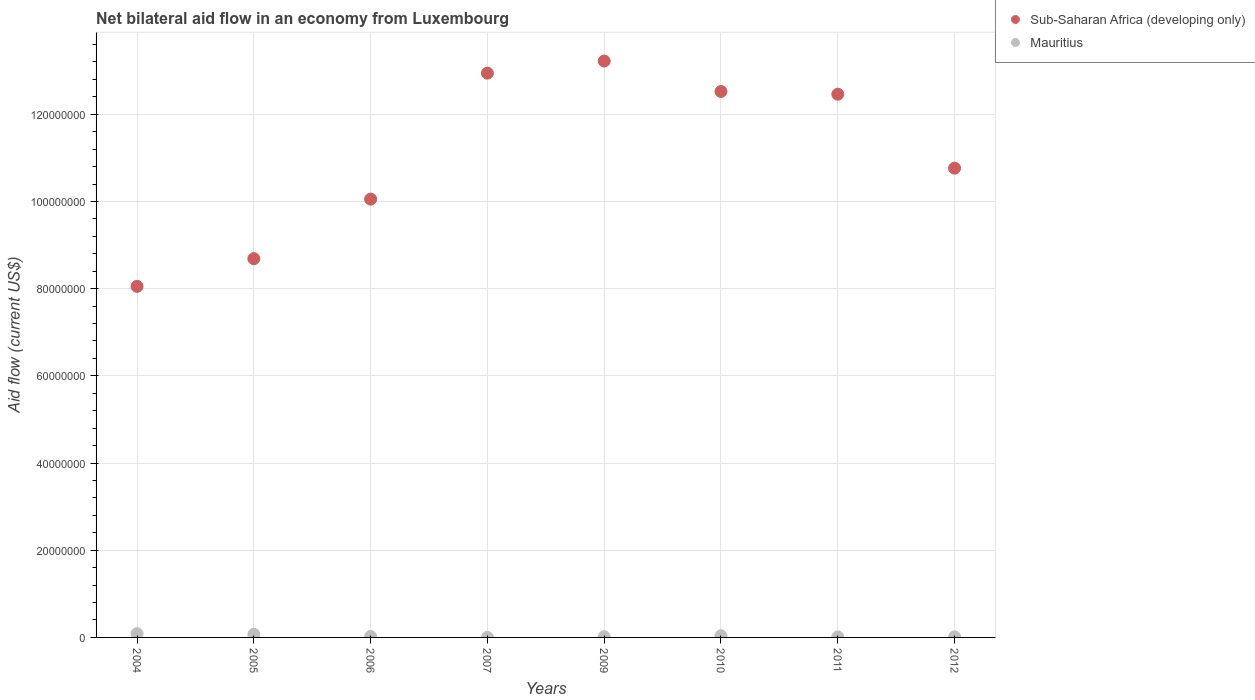How many different coloured dotlines are there?
Give a very brief answer. 2. Is the number of dotlines equal to the number of legend labels?
Provide a short and direct response. Yes. What is the net bilateral aid flow in Sub-Saharan Africa (developing only) in 2006?
Offer a terse response. 1.01e+08. Across all years, what is the maximum net bilateral aid flow in Mauritius?
Your answer should be very brief. 8.60e+05. Across all years, what is the minimum net bilateral aid flow in Sub-Saharan Africa (developing only)?
Your answer should be very brief. 8.05e+07. In which year was the net bilateral aid flow in Mauritius maximum?
Provide a short and direct response. 2004. In which year was the net bilateral aid flow in Sub-Saharan Africa (developing only) minimum?
Keep it short and to the point. 2004. What is the total net bilateral aid flow in Mauritius in the graph?
Your answer should be compact. 2.58e+06. What is the difference between the net bilateral aid flow in Sub-Saharan Africa (developing only) in 2006 and that in 2009?
Keep it short and to the point. -3.17e+07. What is the difference between the net bilateral aid flow in Sub-Saharan Africa (developing only) in 2005 and the net bilateral aid flow in Mauritius in 2007?
Offer a terse response. 8.69e+07. What is the average net bilateral aid flow in Sub-Saharan Africa (developing only) per year?
Provide a succinct answer. 1.11e+08. In the year 2010, what is the difference between the net bilateral aid flow in Sub-Saharan Africa (developing only) and net bilateral aid flow in Mauritius?
Provide a short and direct response. 1.25e+08. In how many years, is the net bilateral aid flow in Sub-Saharan Africa (developing only) greater than 84000000 US$?
Your answer should be compact. 7. What is the ratio of the net bilateral aid flow in Sub-Saharan Africa (developing only) in 2006 to that in 2011?
Offer a terse response. 0.81. Is the net bilateral aid flow in Sub-Saharan Africa (developing only) in 2007 less than that in 2012?
Offer a terse response. No. What is the difference between the highest and the second highest net bilateral aid flow in Sub-Saharan Africa (developing only)?
Provide a succinct answer. 2.77e+06. What is the difference between the highest and the lowest net bilateral aid flow in Sub-Saharan Africa (developing only)?
Your answer should be very brief. 5.17e+07. Is the sum of the net bilateral aid flow in Sub-Saharan Africa (developing only) in 2004 and 2012 greater than the maximum net bilateral aid flow in Mauritius across all years?
Offer a terse response. Yes. How many dotlines are there?
Make the answer very short. 2. How many years are there in the graph?
Ensure brevity in your answer.  8. Are the values on the major ticks of Y-axis written in scientific E-notation?
Your response must be concise. No. Does the graph contain any zero values?
Your answer should be very brief. No. What is the title of the graph?
Offer a very short reply. Net bilateral aid flow in an economy from Luxembourg. Does "Cayman Islands" appear as one of the legend labels in the graph?
Offer a terse response. No. What is the label or title of the Y-axis?
Make the answer very short. Aid flow (current US$). What is the Aid flow (current US$) in Sub-Saharan Africa (developing only) in 2004?
Offer a very short reply. 8.05e+07. What is the Aid flow (current US$) of Mauritius in 2004?
Provide a succinct answer. 8.60e+05. What is the Aid flow (current US$) of Sub-Saharan Africa (developing only) in 2005?
Keep it short and to the point. 8.69e+07. What is the Aid flow (current US$) in Mauritius in 2005?
Provide a short and direct response. 7.20e+05. What is the Aid flow (current US$) of Sub-Saharan Africa (developing only) in 2006?
Provide a short and direct response. 1.01e+08. What is the Aid flow (current US$) of Mauritius in 2006?
Keep it short and to the point. 2.10e+05. What is the Aid flow (current US$) in Sub-Saharan Africa (developing only) in 2007?
Offer a terse response. 1.29e+08. What is the Aid flow (current US$) in Sub-Saharan Africa (developing only) in 2009?
Provide a short and direct response. 1.32e+08. What is the Aid flow (current US$) in Sub-Saharan Africa (developing only) in 2010?
Offer a terse response. 1.25e+08. What is the Aid flow (current US$) in Sub-Saharan Africa (developing only) in 2011?
Make the answer very short. 1.25e+08. What is the Aid flow (current US$) in Sub-Saharan Africa (developing only) in 2012?
Provide a succinct answer. 1.08e+08. What is the Aid flow (current US$) of Mauritius in 2012?
Offer a terse response. 1.30e+05. Across all years, what is the maximum Aid flow (current US$) of Sub-Saharan Africa (developing only)?
Make the answer very short. 1.32e+08. Across all years, what is the maximum Aid flow (current US$) of Mauritius?
Make the answer very short. 8.60e+05. Across all years, what is the minimum Aid flow (current US$) of Sub-Saharan Africa (developing only)?
Provide a short and direct response. 8.05e+07. Across all years, what is the minimum Aid flow (current US$) of Mauritius?
Ensure brevity in your answer.  2.00e+04. What is the total Aid flow (current US$) in Sub-Saharan Africa (developing only) in the graph?
Ensure brevity in your answer.  8.87e+08. What is the total Aid flow (current US$) in Mauritius in the graph?
Your answer should be compact. 2.58e+06. What is the difference between the Aid flow (current US$) in Sub-Saharan Africa (developing only) in 2004 and that in 2005?
Give a very brief answer. -6.36e+06. What is the difference between the Aid flow (current US$) in Sub-Saharan Africa (developing only) in 2004 and that in 2006?
Provide a succinct answer. -2.00e+07. What is the difference between the Aid flow (current US$) of Mauritius in 2004 and that in 2006?
Keep it short and to the point. 6.50e+05. What is the difference between the Aid flow (current US$) in Sub-Saharan Africa (developing only) in 2004 and that in 2007?
Keep it short and to the point. -4.89e+07. What is the difference between the Aid flow (current US$) of Mauritius in 2004 and that in 2007?
Keep it short and to the point. 8.40e+05. What is the difference between the Aid flow (current US$) in Sub-Saharan Africa (developing only) in 2004 and that in 2009?
Keep it short and to the point. -5.17e+07. What is the difference between the Aid flow (current US$) in Mauritius in 2004 and that in 2009?
Make the answer very short. 7.10e+05. What is the difference between the Aid flow (current US$) in Sub-Saharan Africa (developing only) in 2004 and that in 2010?
Give a very brief answer. -4.47e+07. What is the difference between the Aid flow (current US$) of Mauritius in 2004 and that in 2010?
Make the answer very short. 4.90e+05. What is the difference between the Aid flow (current US$) of Sub-Saharan Africa (developing only) in 2004 and that in 2011?
Your answer should be compact. -4.41e+07. What is the difference between the Aid flow (current US$) in Mauritius in 2004 and that in 2011?
Offer a terse response. 7.40e+05. What is the difference between the Aid flow (current US$) of Sub-Saharan Africa (developing only) in 2004 and that in 2012?
Offer a very short reply. -2.71e+07. What is the difference between the Aid flow (current US$) of Mauritius in 2004 and that in 2012?
Your answer should be very brief. 7.30e+05. What is the difference between the Aid flow (current US$) in Sub-Saharan Africa (developing only) in 2005 and that in 2006?
Provide a short and direct response. -1.37e+07. What is the difference between the Aid flow (current US$) of Mauritius in 2005 and that in 2006?
Provide a succinct answer. 5.10e+05. What is the difference between the Aid flow (current US$) in Sub-Saharan Africa (developing only) in 2005 and that in 2007?
Make the answer very short. -4.26e+07. What is the difference between the Aid flow (current US$) in Sub-Saharan Africa (developing only) in 2005 and that in 2009?
Ensure brevity in your answer.  -4.53e+07. What is the difference between the Aid flow (current US$) of Mauritius in 2005 and that in 2009?
Provide a succinct answer. 5.70e+05. What is the difference between the Aid flow (current US$) of Sub-Saharan Africa (developing only) in 2005 and that in 2010?
Ensure brevity in your answer.  -3.84e+07. What is the difference between the Aid flow (current US$) in Sub-Saharan Africa (developing only) in 2005 and that in 2011?
Provide a succinct answer. -3.77e+07. What is the difference between the Aid flow (current US$) of Sub-Saharan Africa (developing only) in 2005 and that in 2012?
Provide a succinct answer. -2.08e+07. What is the difference between the Aid flow (current US$) in Mauritius in 2005 and that in 2012?
Provide a short and direct response. 5.90e+05. What is the difference between the Aid flow (current US$) of Sub-Saharan Africa (developing only) in 2006 and that in 2007?
Your answer should be compact. -2.89e+07. What is the difference between the Aid flow (current US$) of Sub-Saharan Africa (developing only) in 2006 and that in 2009?
Your response must be concise. -3.17e+07. What is the difference between the Aid flow (current US$) of Mauritius in 2006 and that in 2009?
Provide a short and direct response. 6.00e+04. What is the difference between the Aid flow (current US$) in Sub-Saharan Africa (developing only) in 2006 and that in 2010?
Offer a very short reply. -2.47e+07. What is the difference between the Aid flow (current US$) in Mauritius in 2006 and that in 2010?
Provide a succinct answer. -1.60e+05. What is the difference between the Aid flow (current US$) of Sub-Saharan Africa (developing only) in 2006 and that in 2011?
Offer a very short reply. -2.40e+07. What is the difference between the Aid flow (current US$) in Mauritius in 2006 and that in 2011?
Ensure brevity in your answer.  9.00e+04. What is the difference between the Aid flow (current US$) in Sub-Saharan Africa (developing only) in 2006 and that in 2012?
Provide a succinct answer. -7.09e+06. What is the difference between the Aid flow (current US$) in Sub-Saharan Africa (developing only) in 2007 and that in 2009?
Your answer should be compact. -2.77e+06. What is the difference between the Aid flow (current US$) of Sub-Saharan Africa (developing only) in 2007 and that in 2010?
Keep it short and to the point. 4.20e+06. What is the difference between the Aid flow (current US$) of Mauritius in 2007 and that in 2010?
Keep it short and to the point. -3.50e+05. What is the difference between the Aid flow (current US$) in Sub-Saharan Africa (developing only) in 2007 and that in 2011?
Your answer should be very brief. 4.84e+06. What is the difference between the Aid flow (current US$) of Sub-Saharan Africa (developing only) in 2007 and that in 2012?
Provide a short and direct response. 2.18e+07. What is the difference between the Aid flow (current US$) in Sub-Saharan Africa (developing only) in 2009 and that in 2010?
Your answer should be compact. 6.97e+06. What is the difference between the Aid flow (current US$) of Sub-Saharan Africa (developing only) in 2009 and that in 2011?
Offer a terse response. 7.61e+06. What is the difference between the Aid flow (current US$) of Sub-Saharan Africa (developing only) in 2009 and that in 2012?
Offer a very short reply. 2.46e+07. What is the difference between the Aid flow (current US$) in Sub-Saharan Africa (developing only) in 2010 and that in 2011?
Provide a succinct answer. 6.40e+05. What is the difference between the Aid flow (current US$) in Mauritius in 2010 and that in 2011?
Make the answer very short. 2.50e+05. What is the difference between the Aid flow (current US$) in Sub-Saharan Africa (developing only) in 2010 and that in 2012?
Give a very brief answer. 1.76e+07. What is the difference between the Aid flow (current US$) of Sub-Saharan Africa (developing only) in 2011 and that in 2012?
Provide a short and direct response. 1.70e+07. What is the difference between the Aid flow (current US$) of Mauritius in 2011 and that in 2012?
Offer a very short reply. -10000. What is the difference between the Aid flow (current US$) in Sub-Saharan Africa (developing only) in 2004 and the Aid flow (current US$) in Mauritius in 2005?
Give a very brief answer. 7.98e+07. What is the difference between the Aid flow (current US$) of Sub-Saharan Africa (developing only) in 2004 and the Aid flow (current US$) of Mauritius in 2006?
Provide a short and direct response. 8.03e+07. What is the difference between the Aid flow (current US$) of Sub-Saharan Africa (developing only) in 2004 and the Aid flow (current US$) of Mauritius in 2007?
Your answer should be very brief. 8.05e+07. What is the difference between the Aid flow (current US$) in Sub-Saharan Africa (developing only) in 2004 and the Aid flow (current US$) in Mauritius in 2009?
Make the answer very short. 8.04e+07. What is the difference between the Aid flow (current US$) in Sub-Saharan Africa (developing only) in 2004 and the Aid flow (current US$) in Mauritius in 2010?
Offer a terse response. 8.02e+07. What is the difference between the Aid flow (current US$) of Sub-Saharan Africa (developing only) in 2004 and the Aid flow (current US$) of Mauritius in 2011?
Your response must be concise. 8.04e+07. What is the difference between the Aid flow (current US$) of Sub-Saharan Africa (developing only) in 2004 and the Aid flow (current US$) of Mauritius in 2012?
Your answer should be compact. 8.04e+07. What is the difference between the Aid flow (current US$) of Sub-Saharan Africa (developing only) in 2005 and the Aid flow (current US$) of Mauritius in 2006?
Offer a very short reply. 8.67e+07. What is the difference between the Aid flow (current US$) of Sub-Saharan Africa (developing only) in 2005 and the Aid flow (current US$) of Mauritius in 2007?
Your answer should be compact. 8.69e+07. What is the difference between the Aid flow (current US$) in Sub-Saharan Africa (developing only) in 2005 and the Aid flow (current US$) in Mauritius in 2009?
Keep it short and to the point. 8.67e+07. What is the difference between the Aid flow (current US$) of Sub-Saharan Africa (developing only) in 2005 and the Aid flow (current US$) of Mauritius in 2010?
Ensure brevity in your answer.  8.65e+07. What is the difference between the Aid flow (current US$) in Sub-Saharan Africa (developing only) in 2005 and the Aid flow (current US$) in Mauritius in 2011?
Keep it short and to the point. 8.68e+07. What is the difference between the Aid flow (current US$) of Sub-Saharan Africa (developing only) in 2005 and the Aid flow (current US$) of Mauritius in 2012?
Your answer should be compact. 8.68e+07. What is the difference between the Aid flow (current US$) of Sub-Saharan Africa (developing only) in 2006 and the Aid flow (current US$) of Mauritius in 2007?
Keep it short and to the point. 1.01e+08. What is the difference between the Aid flow (current US$) of Sub-Saharan Africa (developing only) in 2006 and the Aid flow (current US$) of Mauritius in 2009?
Provide a succinct answer. 1.00e+08. What is the difference between the Aid flow (current US$) of Sub-Saharan Africa (developing only) in 2006 and the Aid flow (current US$) of Mauritius in 2010?
Give a very brief answer. 1.00e+08. What is the difference between the Aid flow (current US$) in Sub-Saharan Africa (developing only) in 2006 and the Aid flow (current US$) in Mauritius in 2011?
Your answer should be very brief. 1.00e+08. What is the difference between the Aid flow (current US$) in Sub-Saharan Africa (developing only) in 2006 and the Aid flow (current US$) in Mauritius in 2012?
Make the answer very short. 1.00e+08. What is the difference between the Aid flow (current US$) in Sub-Saharan Africa (developing only) in 2007 and the Aid flow (current US$) in Mauritius in 2009?
Provide a short and direct response. 1.29e+08. What is the difference between the Aid flow (current US$) of Sub-Saharan Africa (developing only) in 2007 and the Aid flow (current US$) of Mauritius in 2010?
Provide a succinct answer. 1.29e+08. What is the difference between the Aid flow (current US$) in Sub-Saharan Africa (developing only) in 2007 and the Aid flow (current US$) in Mauritius in 2011?
Ensure brevity in your answer.  1.29e+08. What is the difference between the Aid flow (current US$) of Sub-Saharan Africa (developing only) in 2007 and the Aid flow (current US$) of Mauritius in 2012?
Provide a succinct answer. 1.29e+08. What is the difference between the Aid flow (current US$) in Sub-Saharan Africa (developing only) in 2009 and the Aid flow (current US$) in Mauritius in 2010?
Provide a short and direct response. 1.32e+08. What is the difference between the Aid flow (current US$) of Sub-Saharan Africa (developing only) in 2009 and the Aid flow (current US$) of Mauritius in 2011?
Your answer should be very brief. 1.32e+08. What is the difference between the Aid flow (current US$) in Sub-Saharan Africa (developing only) in 2009 and the Aid flow (current US$) in Mauritius in 2012?
Provide a short and direct response. 1.32e+08. What is the difference between the Aid flow (current US$) in Sub-Saharan Africa (developing only) in 2010 and the Aid flow (current US$) in Mauritius in 2011?
Give a very brief answer. 1.25e+08. What is the difference between the Aid flow (current US$) of Sub-Saharan Africa (developing only) in 2010 and the Aid flow (current US$) of Mauritius in 2012?
Offer a terse response. 1.25e+08. What is the difference between the Aid flow (current US$) in Sub-Saharan Africa (developing only) in 2011 and the Aid flow (current US$) in Mauritius in 2012?
Ensure brevity in your answer.  1.24e+08. What is the average Aid flow (current US$) of Sub-Saharan Africa (developing only) per year?
Your answer should be very brief. 1.11e+08. What is the average Aid flow (current US$) in Mauritius per year?
Offer a terse response. 3.22e+05. In the year 2004, what is the difference between the Aid flow (current US$) of Sub-Saharan Africa (developing only) and Aid flow (current US$) of Mauritius?
Provide a short and direct response. 7.97e+07. In the year 2005, what is the difference between the Aid flow (current US$) of Sub-Saharan Africa (developing only) and Aid flow (current US$) of Mauritius?
Make the answer very short. 8.62e+07. In the year 2006, what is the difference between the Aid flow (current US$) in Sub-Saharan Africa (developing only) and Aid flow (current US$) in Mauritius?
Make the answer very short. 1.00e+08. In the year 2007, what is the difference between the Aid flow (current US$) in Sub-Saharan Africa (developing only) and Aid flow (current US$) in Mauritius?
Give a very brief answer. 1.29e+08. In the year 2009, what is the difference between the Aid flow (current US$) in Sub-Saharan Africa (developing only) and Aid flow (current US$) in Mauritius?
Make the answer very short. 1.32e+08. In the year 2010, what is the difference between the Aid flow (current US$) in Sub-Saharan Africa (developing only) and Aid flow (current US$) in Mauritius?
Make the answer very short. 1.25e+08. In the year 2011, what is the difference between the Aid flow (current US$) in Sub-Saharan Africa (developing only) and Aid flow (current US$) in Mauritius?
Your answer should be compact. 1.24e+08. In the year 2012, what is the difference between the Aid flow (current US$) of Sub-Saharan Africa (developing only) and Aid flow (current US$) of Mauritius?
Keep it short and to the point. 1.08e+08. What is the ratio of the Aid flow (current US$) in Sub-Saharan Africa (developing only) in 2004 to that in 2005?
Offer a terse response. 0.93. What is the ratio of the Aid flow (current US$) in Mauritius in 2004 to that in 2005?
Make the answer very short. 1.19. What is the ratio of the Aid flow (current US$) of Sub-Saharan Africa (developing only) in 2004 to that in 2006?
Your response must be concise. 0.8. What is the ratio of the Aid flow (current US$) of Mauritius in 2004 to that in 2006?
Your response must be concise. 4.1. What is the ratio of the Aid flow (current US$) in Sub-Saharan Africa (developing only) in 2004 to that in 2007?
Ensure brevity in your answer.  0.62. What is the ratio of the Aid flow (current US$) of Mauritius in 2004 to that in 2007?
Keep it short and to the point. 43. What is the ratio of the Aid flow (current US$) of Sub-Saharan Africa (developing only) in 2004 to that in 2009?
Give a very brief answer. 0.61. What is the ratio of the Aid flow (current US$) of Mauritius in 2004 to that in 2009?
Your response must be concise. 5.73. What is the ratio of the Aid flow (current US$) in Sub-Saharan Africa (developing only) in 2004 to that in 2010?
Your answer should be compact. 0.64. What is the ratio of the Aid flow (current US$) in Mauritius in 2004 to that in 2010?
Offer a terse response. 2.32. What is the ratio of the Aid flow (current US$) of Sub-Saharan Africa (developing only) in 2004 to that in 2011?
Provide a short and direct response. 0.65. What is the ratio of the Aid flow (current US$) of Mauritius in 2004 to that in 2011?
Your answer should be compact. 7.17. What is the ratio of the Aid flow (current US$) of Sub-Saharan Africa (developing only) in 2004 to that in 2012?
Give a very brief answer. 0.75. What is the ratio of the Aid flow (current US$) of Mauritius in 2004 to that in 2012?
Your answer should be very brief. 6.62. What is the ratio of the Aid flow (current US$) of Sub-Saharan Africa (developing only) in 2005 to that in 2006?
Your answer should be compact. 0.86. What is the ratio of the Aid flow (current US$) in Mauritius in 2005 to that in 2006?
Your answer should be very brief. 3.43. What is the ratio of the Aid flow (current US$) of Sub-Saharan Africa (developing only) in 2005 to that in 2007?
Make the answer very short. 0.67. What is the ratio of the Aid flow (current US$) in Mauritius in 2005 to that in 2007?
Keep it short and to the point. 36. What is the ratio of the Aid flow (current US$) in Sub-Saharan Africa (developing only) in 2005 to that in 2009?
Offer a terse response. 0.66. What is the ratio of the Aid flow (current US$) in Mauritius in 2005 to that in 2009?
Make the answer very short. 4.8. What is the ratio of the Aid flow (current US$) of Sub-Saharan Africa (developing only) in 2005 to that in 2010?
Your response must be concise. 0.69. What is the ratio of the Aid flow (current US$) of Mauritius in 2005 to that in 2010?
Your answer should be compact. 1.95. What is the ratio of the Aid flow (current US$) in Sub-Saharan Africa (developing only) in 2005 to that in 2011?
Provide a succinct answer. 0.7. What is the ratio of the Aid flow (current US$) of Mauritius in 2005 to that in 2011?
Your answer should be very brief. 6. What is the ratio of the Aid flow (current US$) of Sub-Saharan Africa (developing only) in 2005 to that in 2012?
Your answer should be compact. 0.81. What is the ratio of the Aid flow (current US$) of Mauritius in 2005 to that in 2012?
Your response must be concise. 5.54. What is the ratio of the Aid flow (current US$) in Sub-Saharan Africa (developing only) in 2006 to that in 2007?
Your response must be concise. 0.78. What is the ratio of the Aid flow (current US$) in Mauritius in 2006 to that in 2007?
Offer a very short reply. 10.5. What is the ratio of the Aid flow (current US$) in Sub-Saharan Africa (developing only) in 2006 to that in 2009?
Offer a very short reply. 0.76. What is the ratio of the Aid flow (current US$) of Mauritius in 2006 to that in 2009?
Your answer should be very brief. 1.4. What is the ratio of the Aid flow (current US$) of Sub-Saharan Africa (developing only) in 2006 to that in 2010?
Give a very brief answer. 0.8. What is the ratio of the Aid flow (current US$) in Mauritius in 2006 to that in 2010?
Offer a very short reply. 0.57. What is the ratio of the Aid flow (current US$) in Sub-Saharan Africa (developing only) in 2006 to that in 2011?
Offer a very short reply. 0.81. What is the ratio of the Aid flow (current US$) in Mauritius in 2006 to that in 2011?
Offer a terse response. 1.75. What is the ratio of the Aid flow (current US$) in Sub-Saharan Africa (developing only) in 2006 to that in 2012?
Make the answer very short. 0.93. What is the ratio of the Aid flow (current US$) of Mauritius in 2006 to that in 2012?
Offer a terse response. 1.62. What is the ratio of the Aid flow (current US$) of Mauritius in 2007 to that in 2009?
Your answer should be compact. 0.13. What is the ratio of the Aid flow (current US$) in Sub-Saharan Africa (developing only) in 2007 to that in 2010?
Keep it short and to the point. 1.03. What is the ratio of the Aid flow (current US$) in Mauritius in 2007 to that in 2010?
Offer a very short reply. 0.05. What is the ratio of the Aid flow (current US$) in Sub-Saharan Africa (developing only) in 2007 to that in 2011?
Your response must be concise. 1.04. What is the ratio of the Aid flow (current US$) of Sub-Saharan Africa (developing only) in 2007 to that in 2012?
Provide a short and direct response. 1.2. What is the ratio of the Aid flow (current US$) in Mauritius in 2007 to that in 2012?
Your answer should be very brief. 0.15. What is the ratio of the Aid flow (current US$) in Sub-Saharan Africa (developing only) in 2009 to that in 2010?
Provide a succinct answer. 1.06. What is the ratio of the Aid flow (current US$) in Mauritius in 2009 to that in 2010?
Your answer should be compact. 0.41. What is the ratio of the Aid flow (current US$) of Sub-Saharan Africa (developing only) in 2009 to that in 2011?
Your answer should be very brief. 1.06. What is the ratio of the Aid flow (current US$) of Sub-Saharan Africa (developing only) in 2009 to that in 2012?
Give a very brief answer. 1.23. What is the ratio of the Aid flow (current US$) in Mauritius in 2009 to that in 2012?
Your answer should be compact. 1.15. What is the ratio of the Aid flow (current US$) in Mauritius in 2010 to that in 2011?
Offer a very short reply. 3.08. What is the ratio of the Aid flow (current US$) in Sub-Saharan Africa (developing only) in 2010 to that in 2012?
Offer a very short reply. 1.16. What is the ratio of the Aid flow (current US$) of Mauritius in 2010 to that in 2012?
Provide a succinct answer. 2.85. What is the ratio of the Aid flow (current US$) in Sub-Saharan Africa (developing only) in 2011 to that in 2012?
Give a very brief answer. 1.16. What is the ratio of the Aid flow (current US$) of Mauritius in 2011 to that in 2012?
Offer a terse response. 0.92. What is the difference between the highest and the second highest Aid flow (current US$) in Sub-Saharan Africa (developing only)?
Offer a very short reply. 2.77e+06. What is the difference between the highest and the lowest Aid flow (current US$) of Sub-Saharan Africa (developing only)?
Your response must be concise. 5.17e+07. What is the difference between the highest and the lowest Aid flow (current US$) of Mauritius?
Your answer should be very brief. 8.40e+05. 